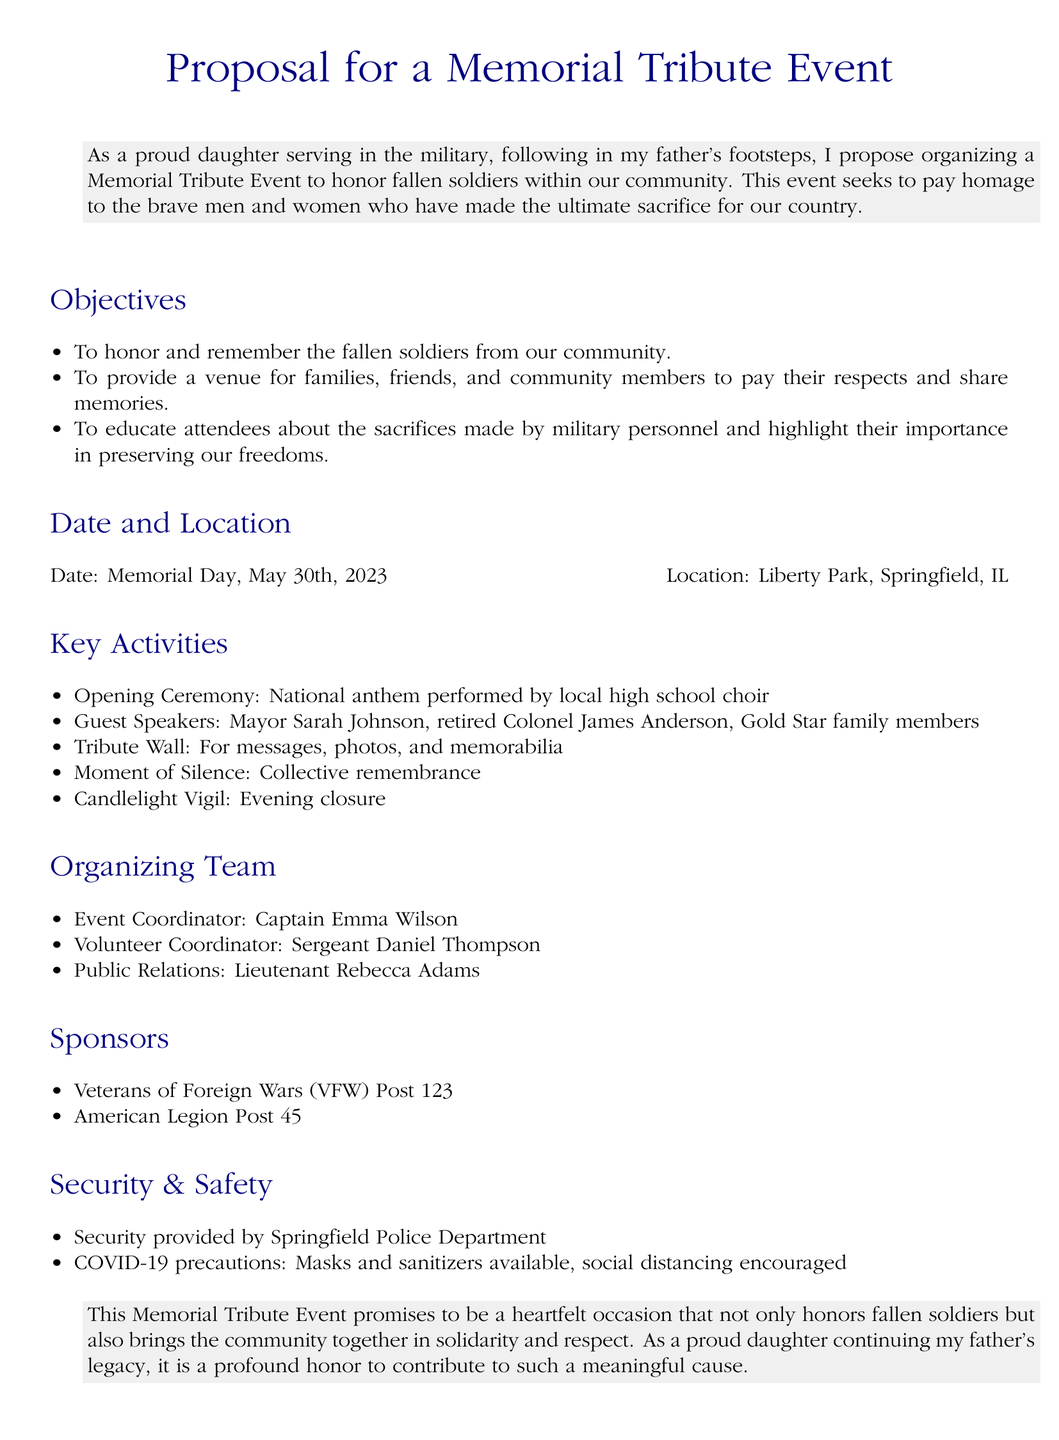What is the proposed date for the event? The date for the event is specified as Memorial Day, which is May 30th, 2023.
Answer: May 30th, 2023 Who is the Event Coordinator? The Event Coordinator is identified in the organizing team section as Captain Emma Wilson.
Answer: Captain Emma Wilson What is one key activity mentioned in the proposal? The key activities section lists several activities; one example is the Opening Ceremony.
Answer: Opening Ceremony Who will perform the national anthem? The document states that the national anthem will be performed by the local high school choir.
Answer: local high school choir What type of safety precautions are mentioned in the proposal? The safety section includes COVID-19 precautions like wearing masks and providing sanitizers.
Answer: Masks and sanitizers What role does Lieutenant Rebecca Adams have in the organizing team? Lieutenant Rebecca Adams is noted for her role in Public Relations in the organizing team section.
Answer: Public Relations Which organizations are listed as sponsors? The sponsors section names two organizations: Veterans of Foreign Wars (VFW) Post 123 and American Legion Post 45.
Answer: Veterans of Foreign Wars (VFW) Post 123 and American Legion Post 45 What is the purpose of the Tribute Wall? The Tribute Wall is intended for messages, photos, and memorabilia to honor fallen soldiers.
Answer: messages, photos, and memorabilia What sentiment does the proposal convey about the event's significance? The proposal expresses that the event is a heartfelt occasion that honors fallen soldiers and brings the community together.
Answer: heartfelt occasion 